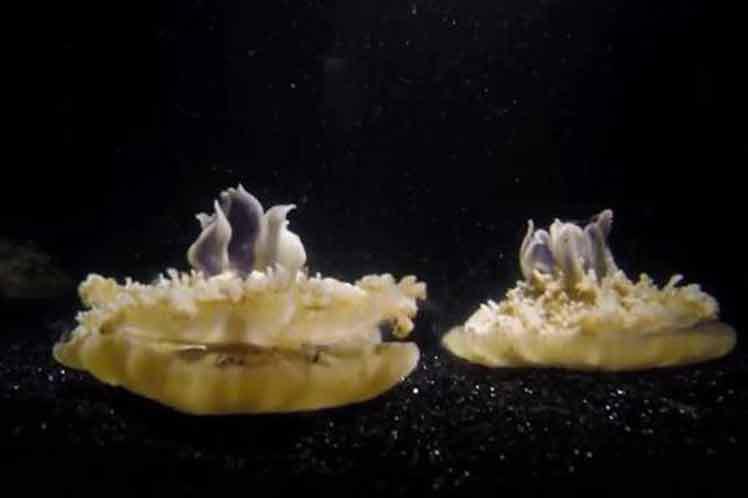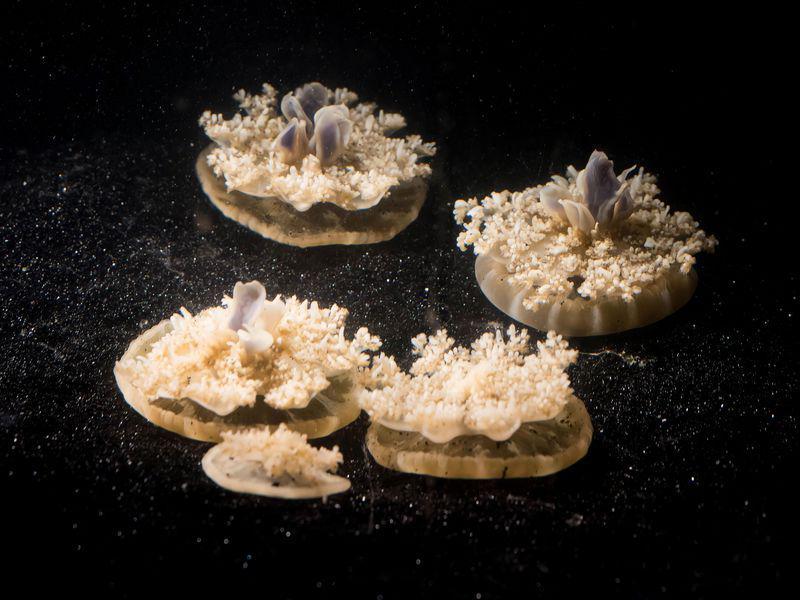The first image is the image on the left, the second image is the image on the right. Assess this claim about the two images: "The jellyfish in the left and right images share the same shape 'caps' and are positioned with their tentacles facing the same direction.". Correct or not? Answer yes or no. Yes. The first image is the image on the left, the second image is the image on the right. For the images shown, is this caption "Exactly one creature is sitting on the bottom." true? Answer yes or no. No. 